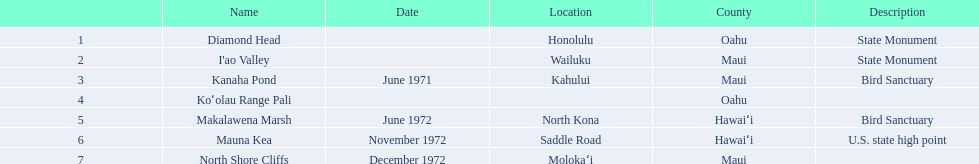What are the various names of landmarks? Diamond Head, I'ao Valley, Kanaha Pond, Koʻolau Range Pali, Makalawena Marsh, Mauna Kea, North Shore Cliffs. Which one is situated in hawai'i county? Makalawena Marsh, Mauna Kea. Which one is not mauna kea? Makalawena Marsh. 